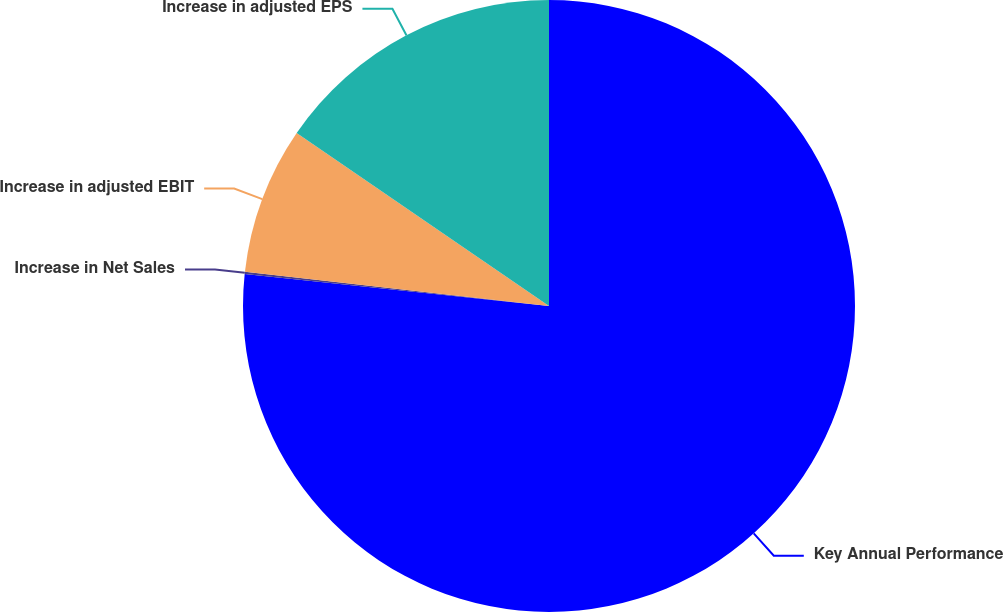Convert chart. <chart><loc_0><loc_0><loc_500><loc_500><pie_chart><fcel>Key Annual Performance<fcel>Increase in Net Sales<fcel>Increase in adjusted EBIT<fcel>Increase in adjusted EPS<nl><fcel>76.67%<fcel>0.12%<fcel>7.78%<fcel>15.43%<nl></chart> 